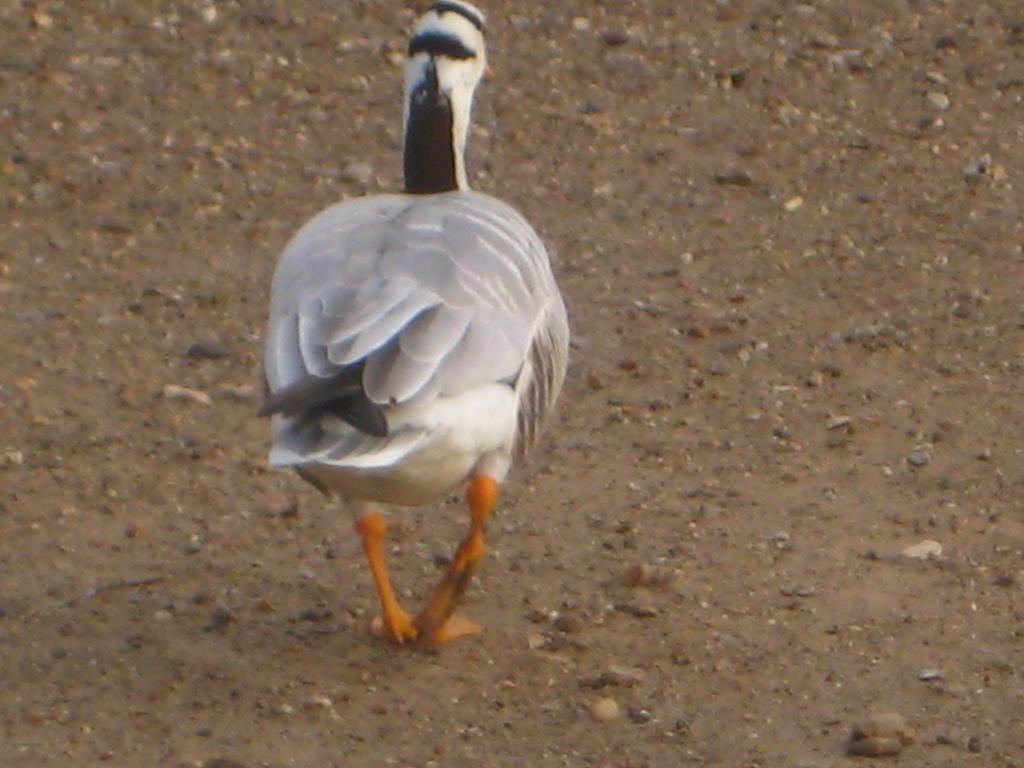Describe this image in one or two sentences. In the picture we can see a bird standing on the mud path, the bird is in white color with some part of black color to the tail and near the neck. 